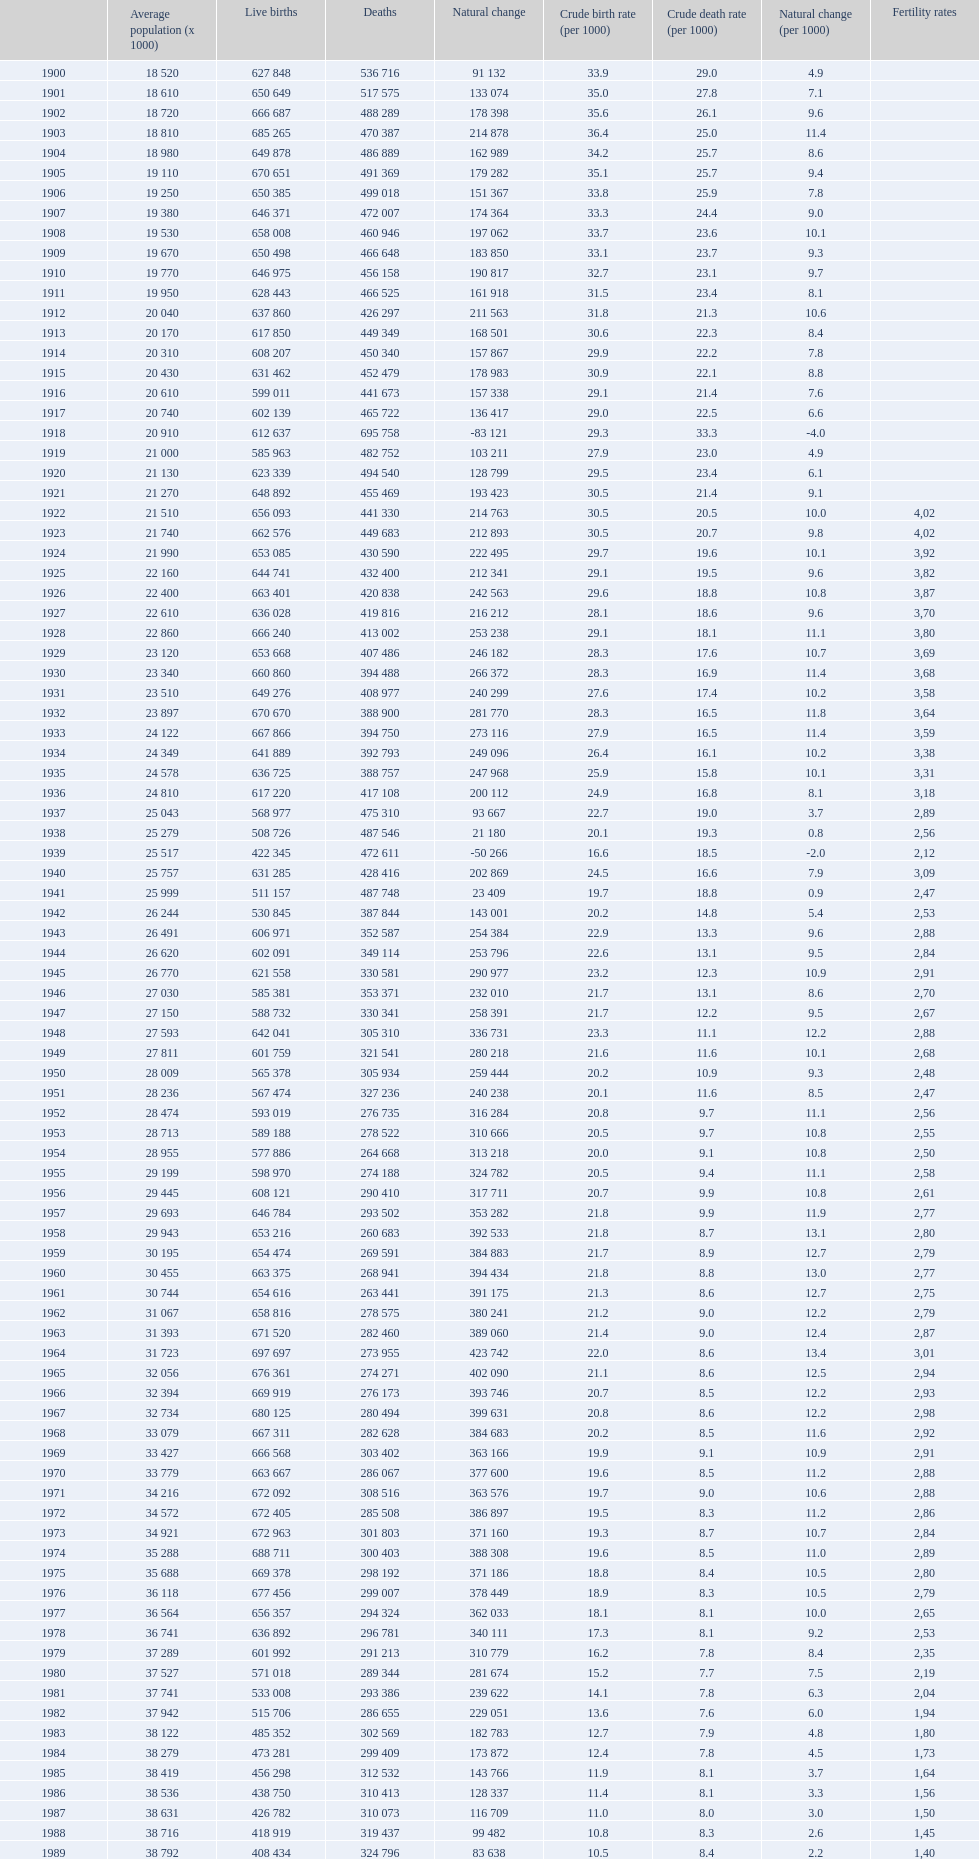In which year did spain show the highest number of live births over deaths? 1964. 